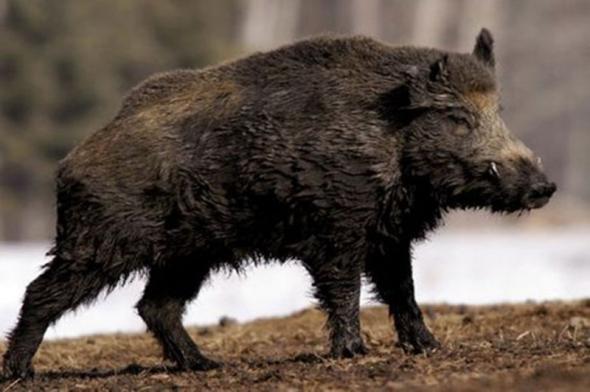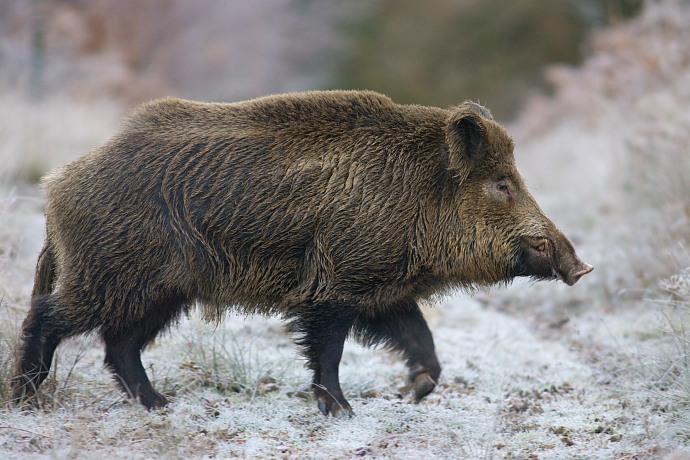The first image is the image on the left, the second image is the image on the right. Given the left and right images, does the statement "In one image the ground is not covered in snow." hold true? Answer yes or no. Yes. The first image is the image on the left, the second image is the image on the right. Assess this claim about the two images: "One of the images of the boar is identical.". Correct or not? Answer yes or no. No. 